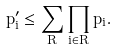<formula> <loc_0><loc_0><loc_500><loc_500>p ^ { \prime } _ { i } \leq \sum _ { R } \prod _ { i \in R } p _ { i } .</formula> 